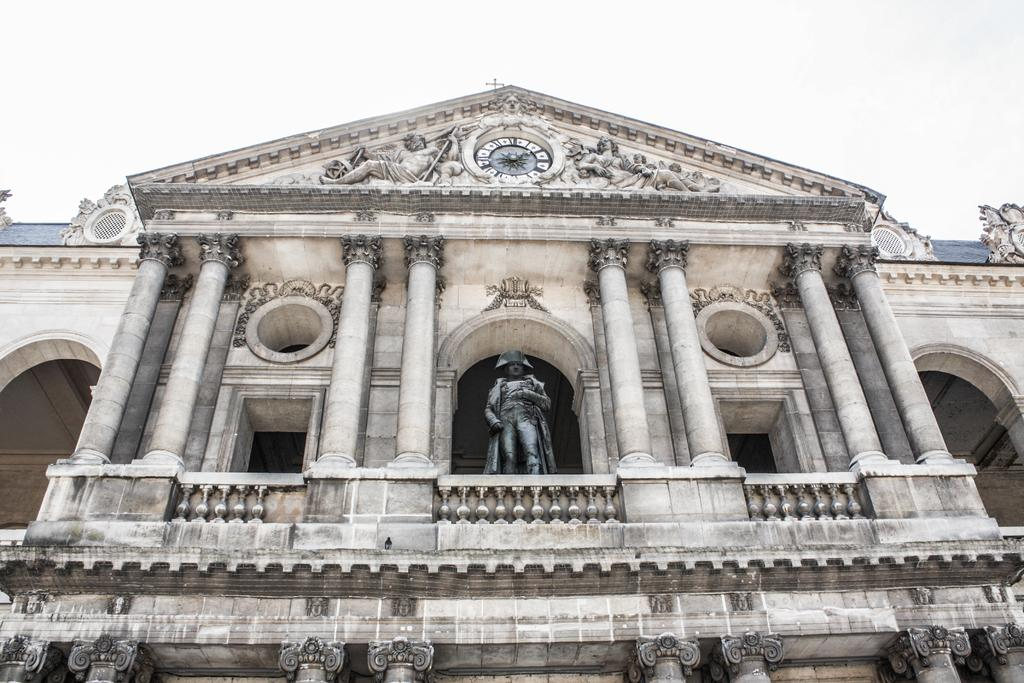What is the color of the building in the image? The building in the image is white-colored. What decorative elements can be seen on the building? There are sculptures on the building. What is the color of the background in the image? The background of the image is white in color. What type of straw is used to solve the riddle in the image? There is no straw or riddle present in the image. 